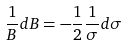<formula> <loc_0><loc_0><loc_500><loc_500>\frac { 1 } { B } d B = - \frac { 1 } { 2 } \frac { 1 } { \sigma } d \sigma</formula> 